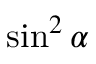<formula> <loc_0><loc_0><loc_500><loc_500>\sin ^ { 2 } \alpha</formula> 